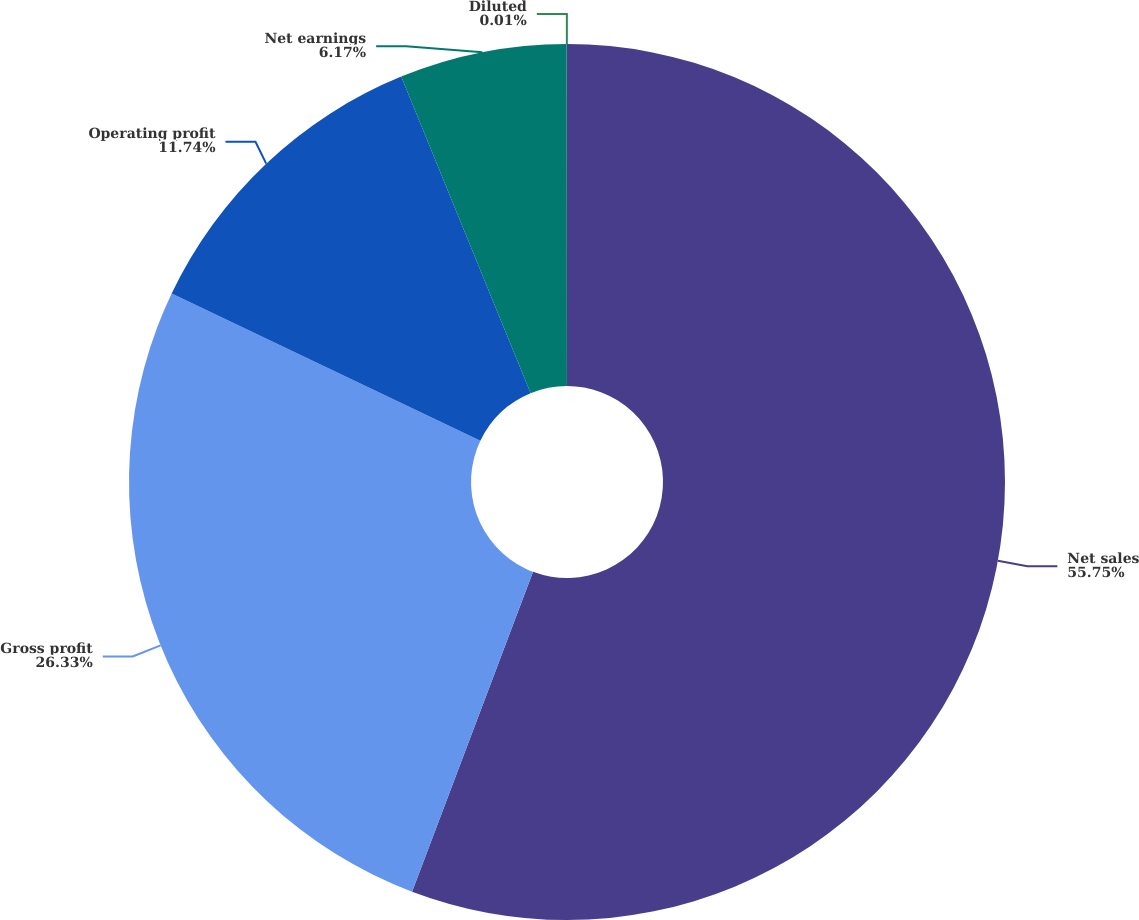Convert chart. <chart><loc_0><loc_0><loc_500><loc_500><pie_chart><fcel>Net sales<fcel>Gross profit<fcel>Operating profit<fcel>Net earnings<fcel>Diluted<nl><fcel>55.76%<fcel>26.33%<fcel>11.74%<fcel>6.17%<fcel>0.01%<nl></chart> 